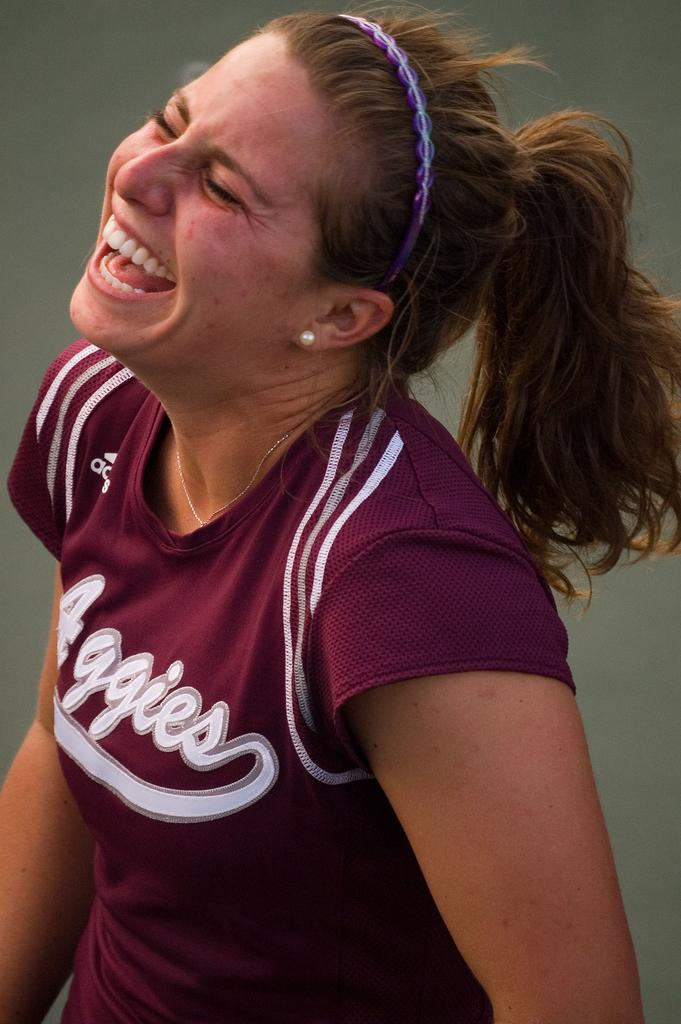<image>
Relay a brief, clear account of the picture shown. The woman with a purple head band is wearing a team jersey by Adidas. 